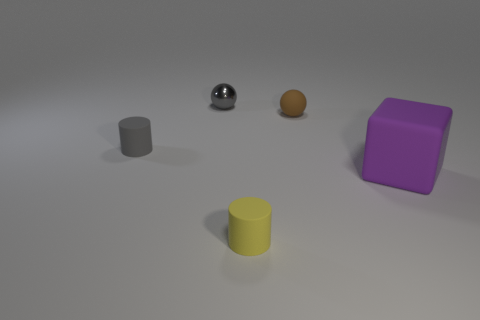Is the number of balls that are on the right side of the brown rubber ball greater than the number of small gray cylinders in front of the large rubber block?
Offer a terse response. No. What shape is the big purple matte thing?
Provide a short and direct response. Cube. Do the object that is to the right of the small brown object and the small object in front of the cube have the same material?
Ensure brevity in your answer.  Yes. What shape is the matte object in front of the big purple rubber object?
Your response must be concise. Cylinder. The gray object that is the same shape as the small yellow thing is what size?
Make the answer very short. Small. Is the color of the metallic ball the same as the big rubber thing?
Make the answer very short. No. Are there any other things that are the same shape as the tiny gray shiny object?
Keep it short and to the point. Yes. There is a rubber cylinder behind the big object; are there any cylinders that are behind it?
Your answer should be very brief. No. What color is the other thing that is the same shape as the tiny brown matte thing?
Your answer should be very brief. Gray. How many small things have the same color as the metal sphere?
Provide a short and direct response. 1. 